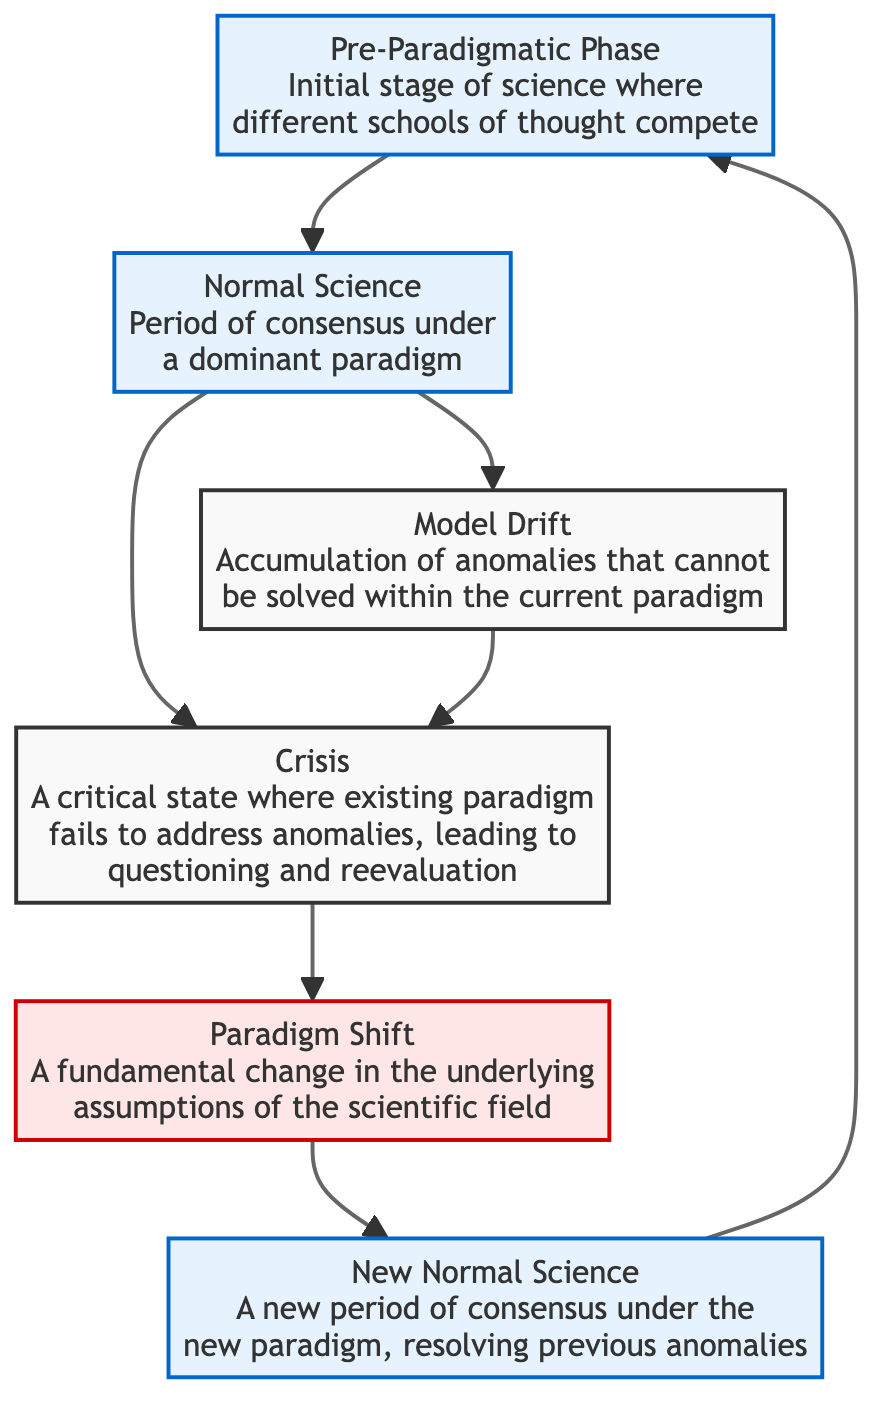What is the first phase in the diagram? The first phase in the diagram starts with the "Pre-Paradigmatic Phase," which is indicated as the initial stage of science where different schools of thought compete. This is represented at the top of the flowchart.
Answer: Pre-Paradigmatic Phase How many phases are depicted in the diagram? By counting the blocks labeled in the diagram, there are a total of 6 distinct phases represented: Pre-Paradigmatic Phase, Normal Science, Model Drift, Crisis, Paradigm Shift, and New Normal Science.
Answer: 6 What is the output of the 'Crisis' block? The 'Crisis' block leads to a 'Paradigm Shift', according to the connection arrows in the flowchart, indicating that experiencing a crisis prompts a significant change in paradigm.
Answer: Paradigm Shift Which block follows 'Model Drift'? The 'Model Drift' block connects to the 'Crisis' block, meaning that when model drift accumulates, it leads directly to a crisis in the scientific understanding or paradigm.
Answer: Crisis What type of change is represented in the 'Paradigm Shift' block? The 'Paradigm Shift' block signifies a fundamental change in the underlying assumptions of the scientific field, as indicated in the description within the block.
Answer: Fundamental change What phases directly connect to 'Normal Science'? The 'Normal Science' block is directly linked to both 'Model Drift' and 'Crisis', suggesting that during this period of consensus, anomalies may arise (model drift) or crises may eventually occur.
Answer: Model Drift, Crisis Describe the relationship between 'New Normal Science' and 'Pre-Paradigmatic Phase.' The 'New Normal Science' block points back to the 'Pre-Paradigmatic Phase', indicating that the scientific process is cyclical, as a new consensus can lead back to new competing schools of thought.
Answer: Cyclical relationship During which phase does the accumulation of anomalies occur? The accumulation of anomalies occurs during the 'Model Drift' phase, as noted in its description which indicates problems that arise within the current paradigm that cannot be solved.
Answer: Model Drift What follows after 'Crisis' in the flowchart? After 'Crisis', the flowchart directly leads to a 'Paradigm Shift', highlighting that a crisis prompts significant changes in scientific paradigms.
Answer: Paradigm Shift 